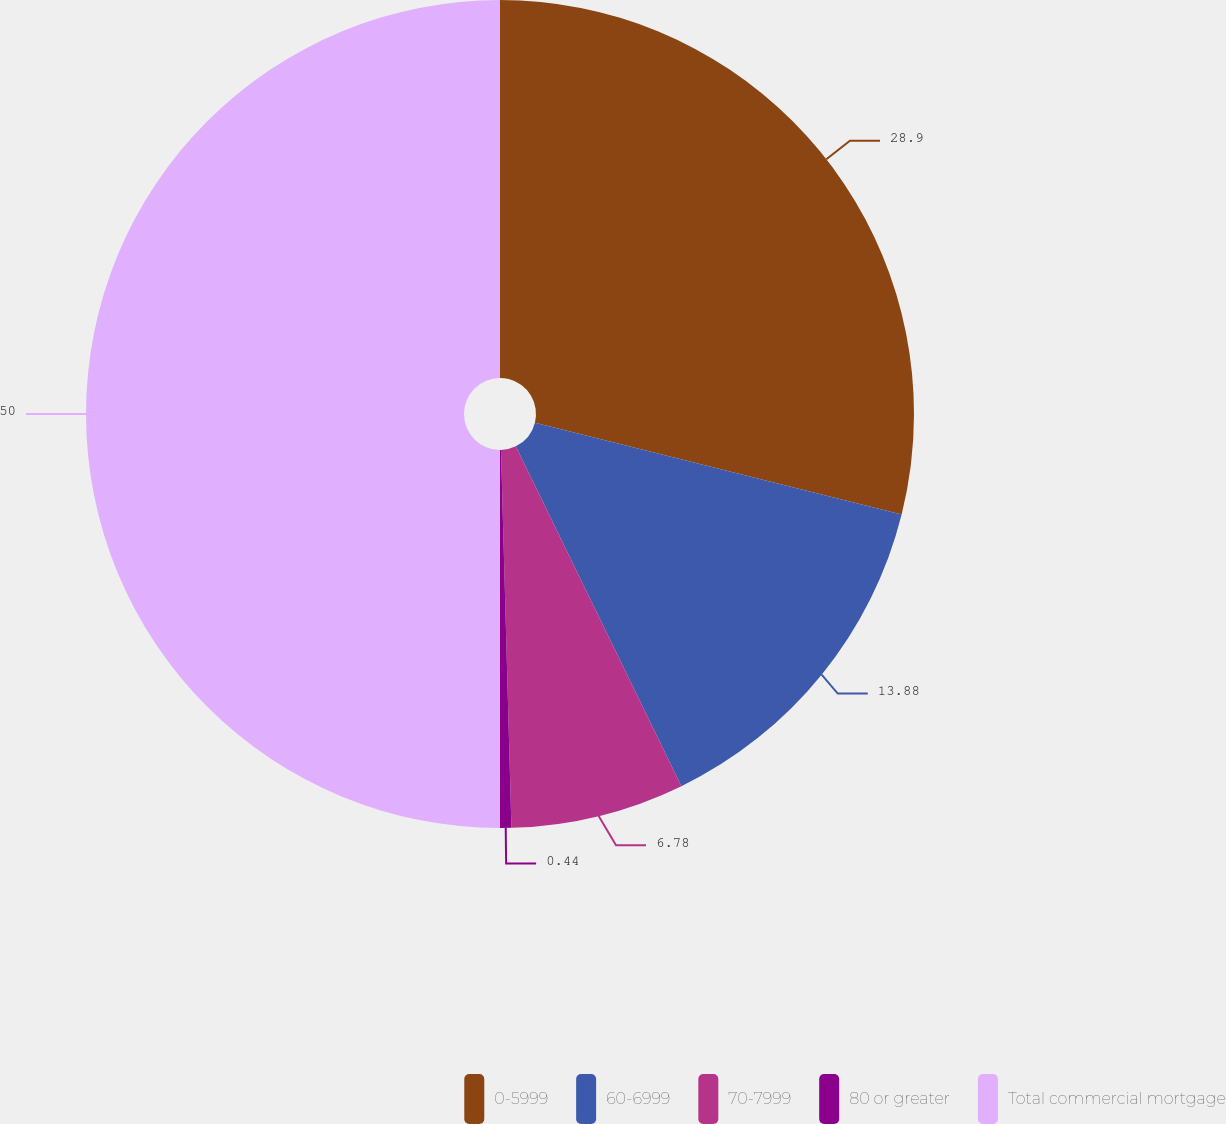<chart> <loc_0><loc_0><loc_500><loc_500><pie_chart><fcel>0-5999<fcel>60-6999<fcel>70-7999<fcel>80 or greater<fcel>Total commercial mortgage<nl><fcel>28.9%<fcel>13.88%<fcel>6.78%<fcel>0.44%<fcel>50.0%<nl></chart> 